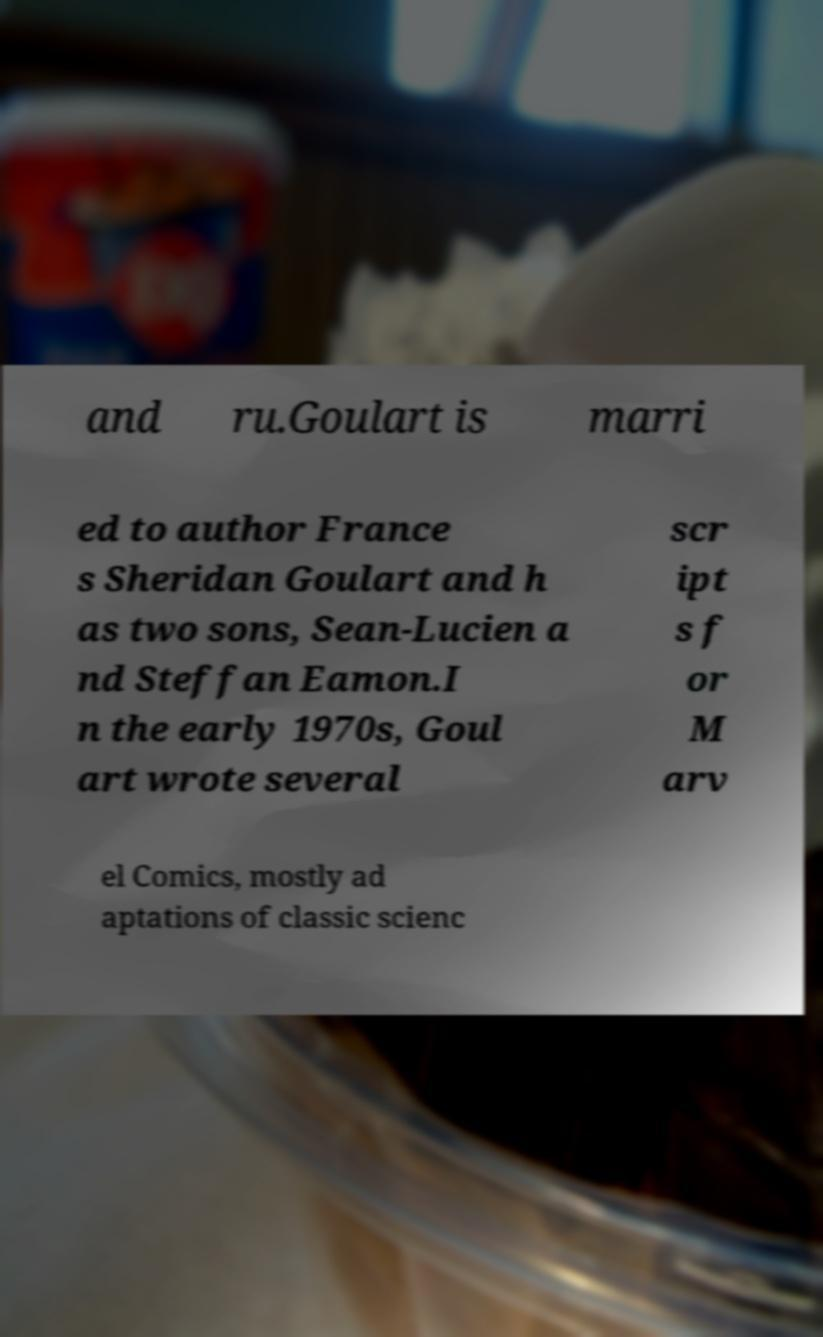Could you assist in decoding the text presented in this image and type it out clearly? and ru.Goulart is marri ed to author France s Sheridan Goulart and h as two sons, Sean-Lucien a nd Steffan Eamon.I n the early 1970s, Goul art wrote several scr ipt s f or M arv el Comics, mostly ad aptations of classic scienc 